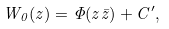Convert formula to latex. <formula><loc_0><loc_0><loc_500><loc_500>W _ { 0 } ( z ) = \Phi ( z \bar { z } ) + C ^ { \prime } ,</formula> 